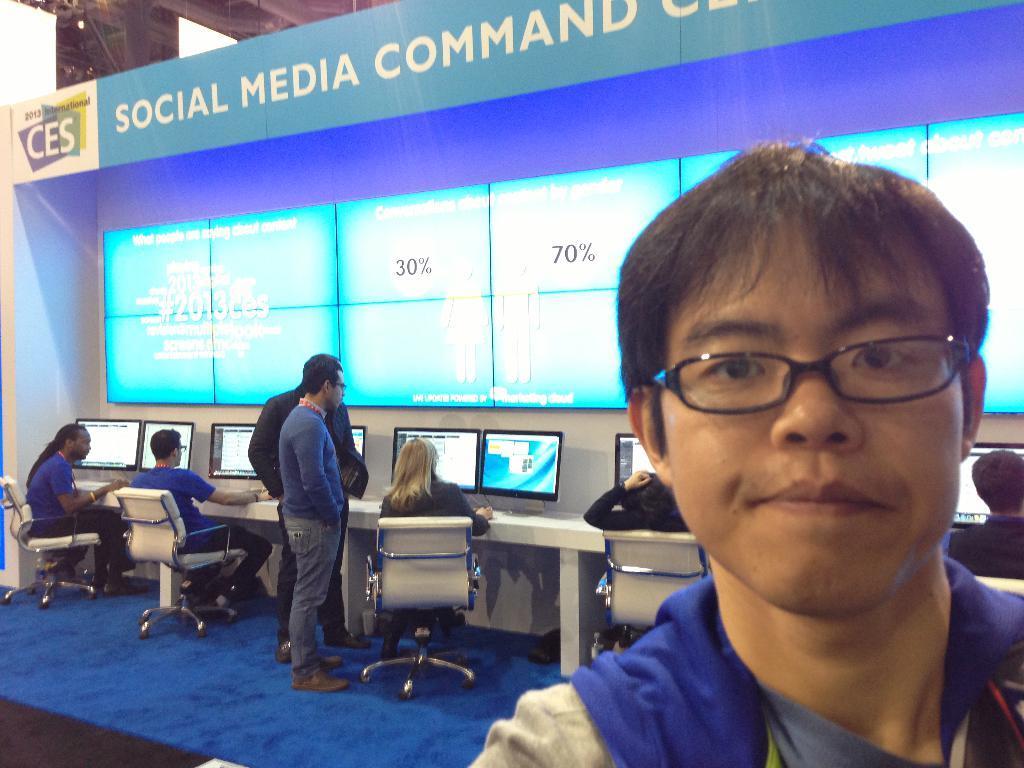How would you summarize this image in a sentence or two? In this image there is a person with spectacles, and in the background there are group of people sitting on the chairs, monitors on the table, screen , board, focus lights. 